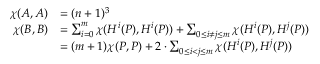Convert formula to latex. <formula><loc_0><loc_0><loc_500><loc_500>\begin{array} { r l } { \chi ( A , A ) } & { = ( n + 1 ) ^ { 3 } } \\ { \chi ( B , B ) } & { = \sum _ { i = 0 } ^ { m } \chi ( H ^ { i } ( P ) , H ^ { i } ( P ) ) + \sum _ { 0 \leq i \neq j \leq m } \chi ( H ^ { i } ( P ) , H ^ { j } ( P ) ) } \\ & { = ( m + 1 ) \chi ( P , P ) + 2 \cdot \sum _ { 0 \leq i < j \leq m } \chi ( H ^ { i } ( P ) , H ^ { j } ( P ) ) } \end{array}</formula> 